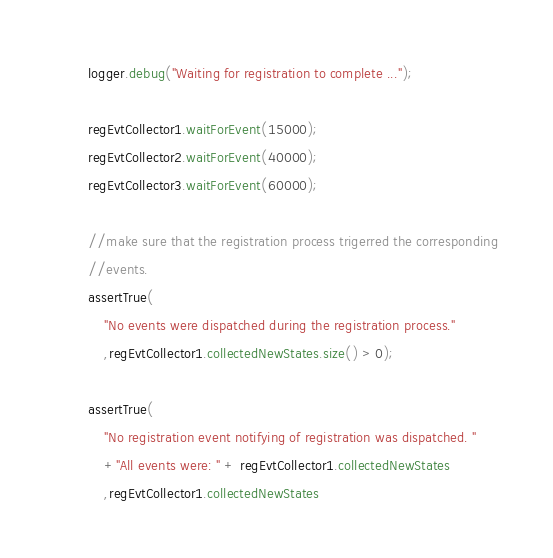<code> <loc_0><loc_0><loc_500><loc_500><_Java_>        logger.debug("Waiting for registration to complete ...");

        regEvtCollector1.waitForEvent(15000);
        regEvtCollector2.waitForEvent(40000);
        regEvtCollector3.waitForEvent(60000);

        //make sure that the registration process trigerred the corresponding
        //events.
        assertTrue(
            "No events were dispatched during the registration process."
            ,regEvtCollector1.collectedNewStates.size() > 0);

        assertTrue(
            "No registration event notifying of registration was dispatched. "
            +"All events were: " + regEvtCollector1.collectedNewStates
            ,regEvtCollector1.collectedNewStates</code> 